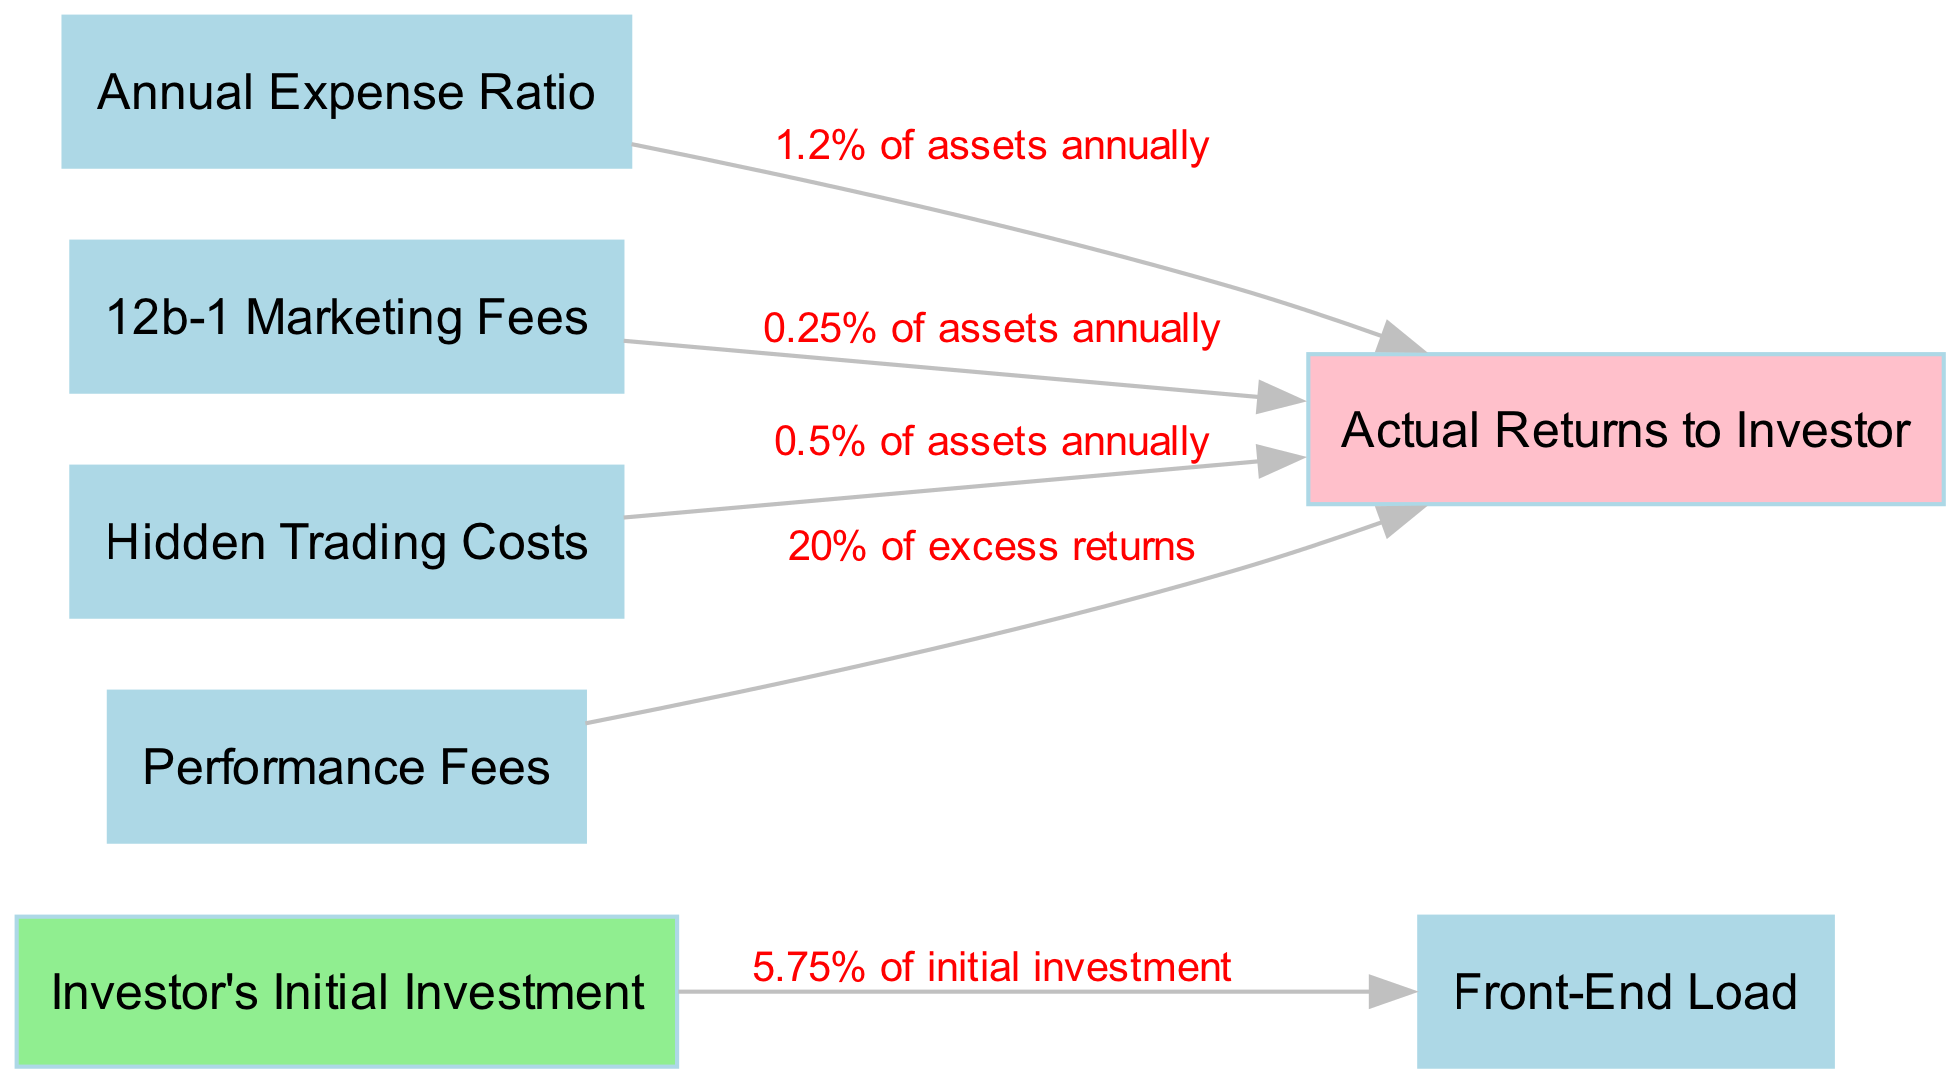What percentage of investor's initial investment is allocated to the front-end load? The diagram shows that the front-end load is 5.75% of the investor's initial investment. This is directly indicated by the edge connecting "Investor's Initial Investment" to "Front-End Load."
Answer: 5.75% What is the total percentage taken by the 12b-1 Marketing Fees, Annual Expense Ratio, and Hidden Trading Costs combined? The 12b-1 Marketing Fees is 0.25%, the Annual Expense Ratio is 1.2%, and the Hidden Trading Costs are 0.5%. Adding these percentages gives 0.25% + 1.2% + 0.5% = 2.0%.
Answer: 2.0% How does performance fees affect actual returns to the investor? The performance fees take away 20% of the excess returns, which means that it directly decreases the "Actual Returns to Investor." This is shown through the edge labeled with the percentage from "Performance Fees" to "Actual Returns to Investor."
Answer: 20% of excess returns How many different types of fees are deducted from the actual returns to the investor? The diagram shows four types of fees that affect the actual returns: Annual Expense Ratio, 12b-1 Marketing Fees, Hidden Trading Costs, and Performance Fees. Thus, there are four distinct types of fees shown.
Answer: 4 What is the nature of the relationship between the investor's initial investment and the front-end load? The front-end load is a direct deduction from the investor's initial investment, indicated by the edge that connects "Investor's Initial Investment" to "Front-End Load." This relationship highlights that the front-end load negatively impacts the amount invested.
Answer: Direct deduction 